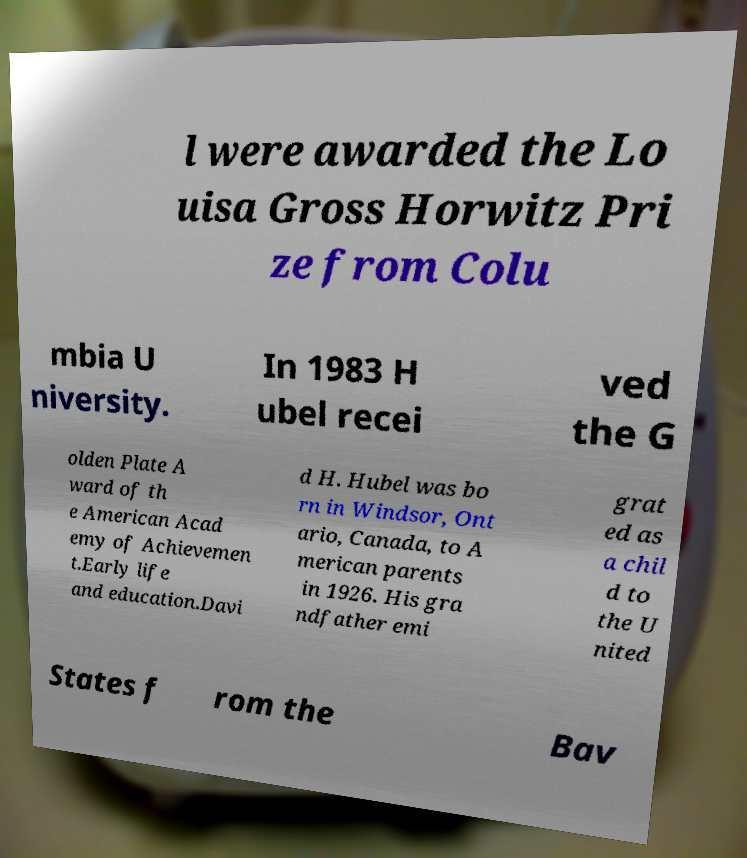Please read and relay the text visible in this image. What does it say? l were awarded the Lo uisa Gross Horwitz Pri ze from Colu mbia U niversity. In 1983 H ubel recei ved the G olden Plate A ward of th e American Acad emy of Achievemen t.Early life and education.Davi d H. Hubel was bo rn in Windsor, Ont ario, Canada, to A merican parents in 1926. His gra ndfather emi grat ed as a chil d to the U nited States f rom the Bav 